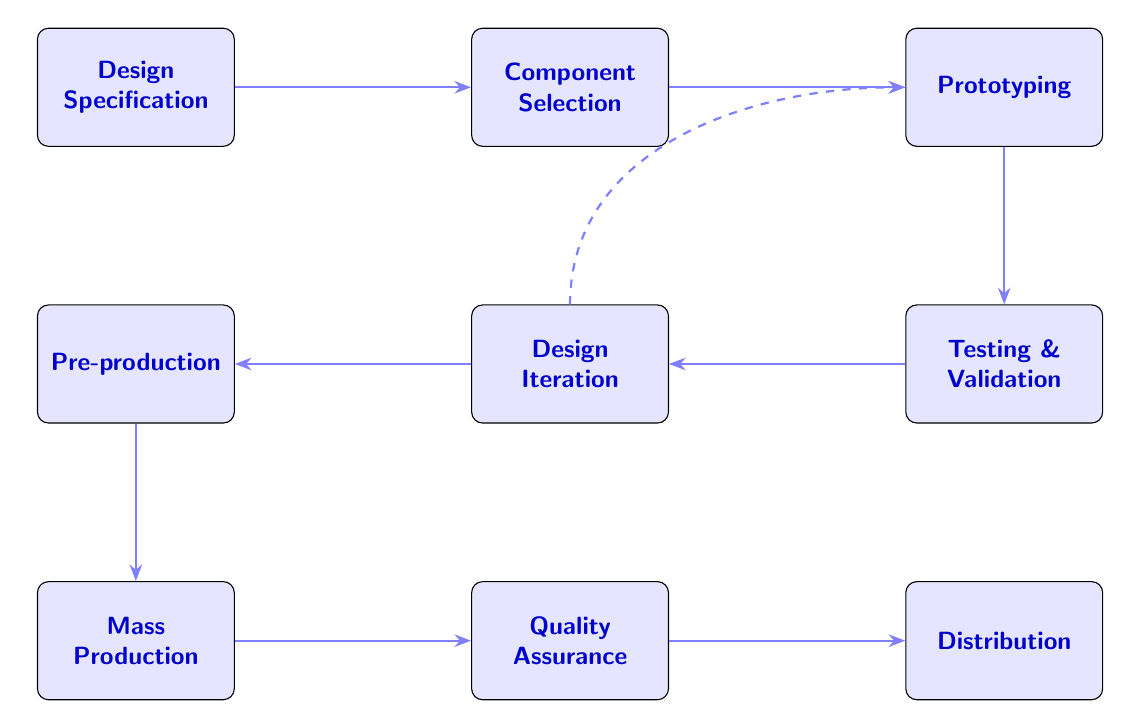What is the first step in the manufacturing process? The first step indicated in the flow chart is "Design Specification," which starts the entire process of manufacturing rugged handheld devices.
Answer: Design Specification How many nodes are present in the diagram? By counting the different rectangular nodes shown in the diagram, there are a total of nine nodes that represent the steps in the manufacturing process.
Answer: 9 What is the third step after component selection? The steps proceed sequentially from "Component Selection" to "Prototyping," making "Prototyping" the third step in the manufacturing process.
Answer: Prototyping What step follows quality assurance? The flow chart shows that the step immediately following "Quality Assurance" is "Distribution," indicating the final phase of the process.
Answer: Distribution What is the connection between testing and design iteration? In the diagram, "Testing & Validation" leads directly to "Design Iteration," as the feedback from testing informs the need for any refinements in the design.
Answer: Design Iteration How do you get back to prototyping from design iteration? The diagram indicates a dashed arrow from "Design Iteration" back to "Prototyping," illustrating that if design changes are needed, the process loops back to the prototyping stage for modifications.
Answer: Through design iteration What must be established before moving to mass production? Before "Mass Production" can commence, the step labeled "Pre-production" must be established, as it involves preparing the manufacturing line and creating pre-production units.
Answer: Pre-production What is the purpose of quality assurance? The purpose of "Quality Assurance" as illustrated in the diagram is to conduct final inspections and quality checks on the mass-produced units to ensure they meet the ruggedness specifications.
Answer: Final inspections What type of testing is highlighted during the testing phase? The diagram highlights "environmental testing," which includes testing for thermal, humidity, vibration, drop tests, and ingress protection (IP) tests during the "Testing & Validation" phase.
Answer: Environmental testing 